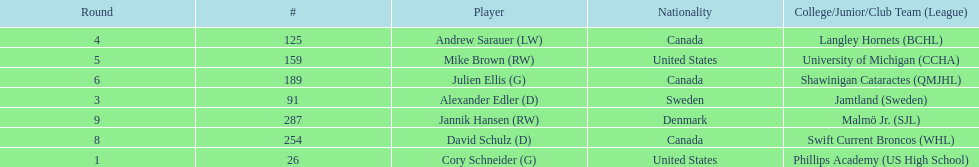Which player was the first player to be drafted? Cory Schneider (G). Parse the table in full. {'header': ['Round', '#', 'Player', 'Nationality', 'College/Junior/Club Team (League)'], 'rows': [['4', '125', 'Andrew Sarauer (LW)', 'Canada', 'Langley Hornets (BCHL)'], ['5', '159', 'Mike Brown (RW)', 'United States', 'University of Michigan (CCHA)'], ['6', '189', 'Julien Ellis (G)', 'Canada', 'Shawinigan Cataractes (QMJHL)'], ['3', '91', 'Alexander Edler (D)', 'Sweden', 'Jamtland (Sweden)'], ['9', '287', 'Jannik Hansen (RW)', 'Denmark', 'Malmö Jr. (SJL)'], ['8', '254', 'David Schulz (D)', 'Canada', 'Swift Current Broncos (WHL)'], ['1', '26', 'Cory Schneider (G)', 'United States', 'Phillips Academy (US High School)']]} 